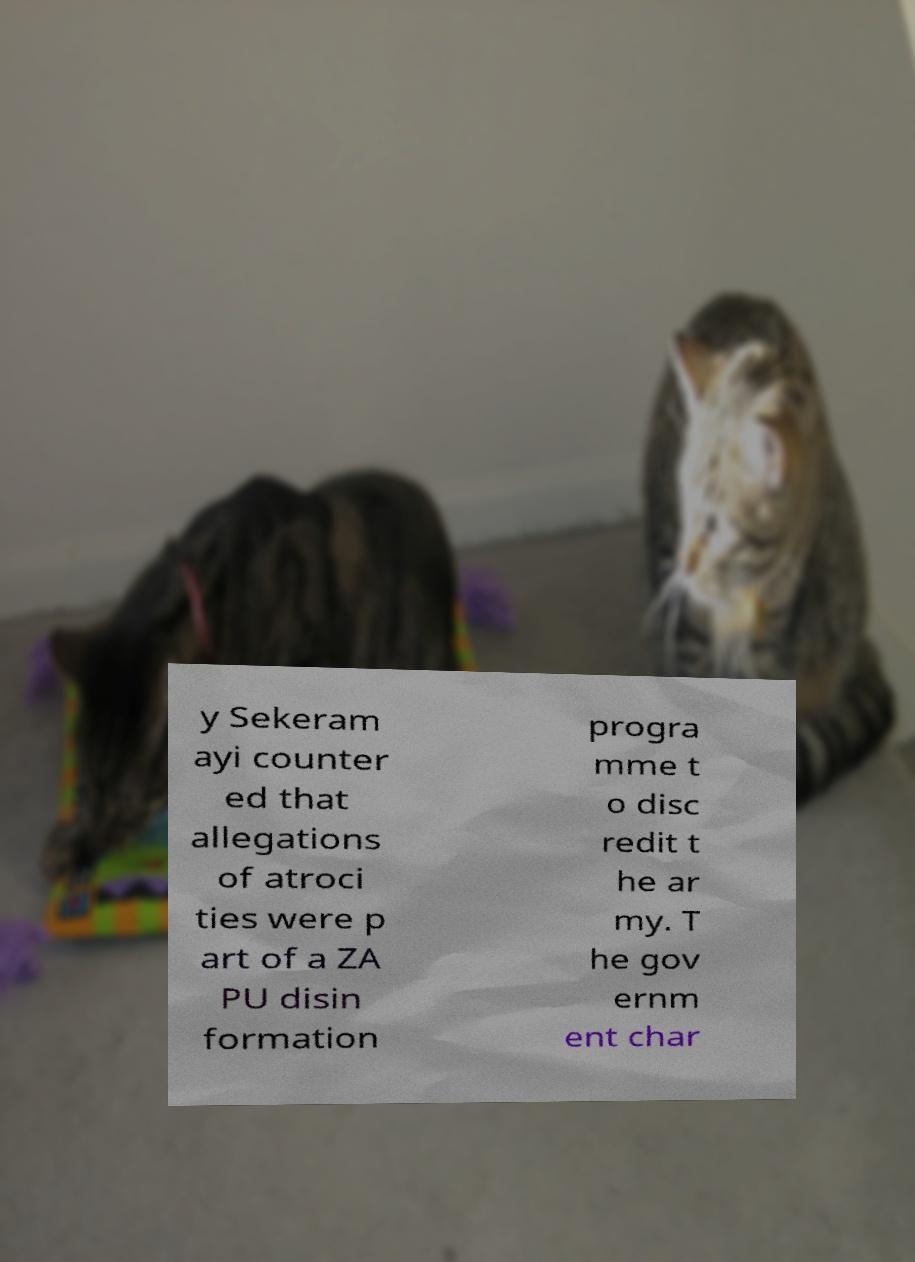I need the written content from this picture converted into text. Can you do that? y Sekeram ayi counter ed that allegations of atroci ties were p art of a ZA PU disin formation progra mme t o disc redit t he ar my. T he gov ernm ent char 